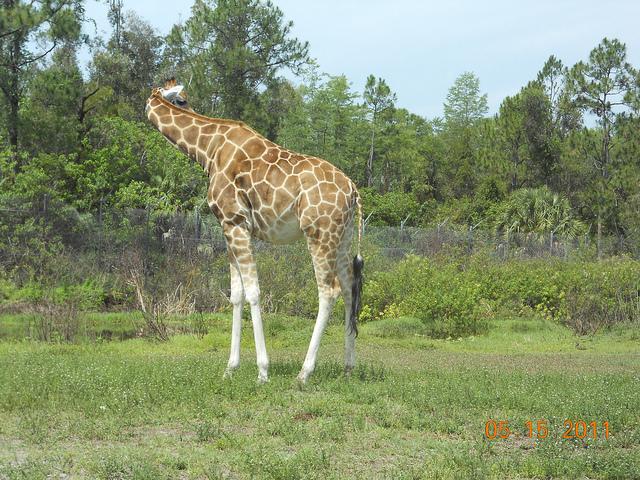How many giraffes are around?
Concise answer only. 1. How many animals?
Short answer required. 1. What year was this picture taken?
Be succinct. 2011. Where does it look like the giraffe lives?
Give a very brief answer. Zoo. Is the giraffe in motion?
Quick response, please. No. Are the animals free?
Be succinct. No. Is this animal in captivity?
Give a very brief answer. Yes. What is on the end of the giraffes hair?
Keep it brief. Tail. 